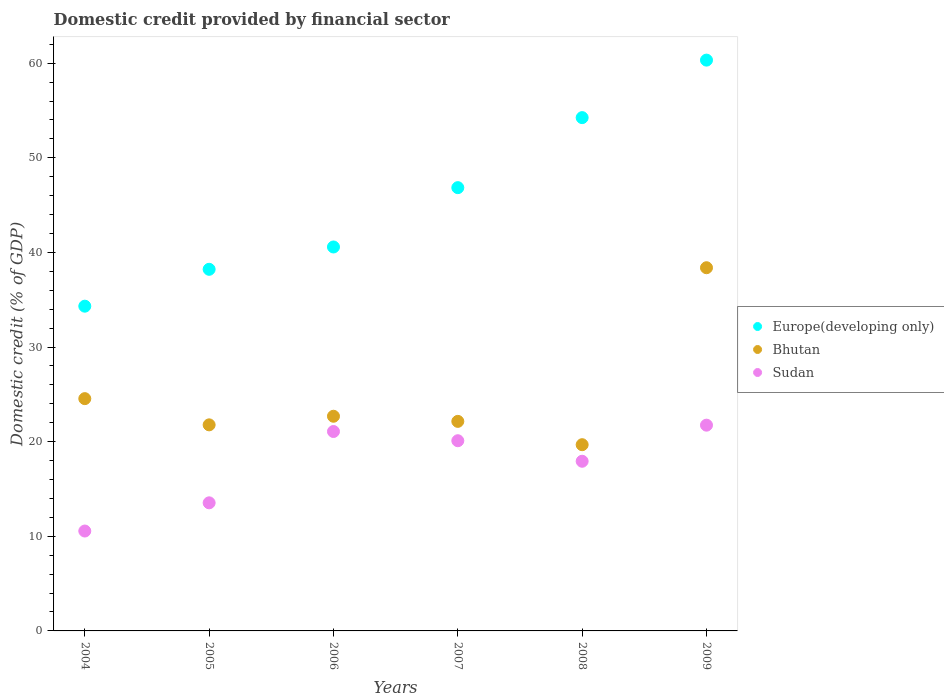What is the domestic credit in Bhutan in 2009?
Give a very brief answer. 38.38. Across all years, what is the maximum domestic credit in Sudan?
Provide a short and direct response. 21.75. Across all years, what is the minimum domestic credit in Bhutan?
Give a very brief answer. 19.68. In which year was the domestic credit in Europe(developing only) maximum?
Offer a terse response. 2009. In which year was the domestic credit in Bhutan minimum?
Offer a very short reply. 2008. What is the total domestic credit in Bhutan in the graph?
Ensure brevity in your answer.  149.23. What is the difference between the domestic credit in Bhutan in 2005 and that in 2008?
Ensure brevity in your answer.  2.1. What is the difference between the domestic credit in Bhutan in 2004 and the domestic credit in Europe(developing only) in 2009?
Provide a succinct answer. -35.78. What is the average domestic credit in Sudan per year?
Your answer should be compact. 17.49. In the year 2006, what is the difference between the domestic credit in Bhutan and domestic credit in Europe(developing only)?
Your response must be concise. -17.89. What is the ratio of the domestic credit in Sudan in 2006 to that in 2008?
Provide a succinct answer. 1.18. Is the domestic credit in Sudan in 2008 less than that in 2009?
Make the answer very short. Yes. What is the difference between the highest and the second highest domestic credit in Bhutan?
Ensure brevity in your answer.  13.84. What is the difference between the highest and the lowest domestic credit in Bhutan?
Make the answer very short. 18.7. In how many years, is the domestic credit in Bhutan greater than the average domestic credit in Bhutan taken over all years?
Offer a very short reply. 1. Is the sum of the domestic credit in Bhutan in 2006 and 2007 greater than the maximum domestic credit in Sudan across all years?
Offer a terse response. Yes. Is it the case that in every year, the sum of the domestic credit in Bhutan and domestic credit in Sudan  is greater than the domestic credit in Europe(developing only)?
Your answer should be compact. No. Does the domestic credit in Europe(developing only) monotonically increase over the years?
Give a very brief answer. Yes. Is the domestic credit in Europe(developing only) strictly greater than the domestic credit in Bhutan over the years?
Ensure brevity in your answer.  Yes. Is the domestic credit in Europe(developing only) strictly less than the domestic credit in Bhutan over the years?
Offer a terse response. No. How many dotlines are there?
Your response must be concise. 3. How many years are there in the graph?
Keep it short and to the point. 6. Does the graph contain any zero values?
Provide a short and direct response. No. Does the graph contain grids?
Offer a terse response. No. How many legend labels are there?
Your answer should be very brief. 3. How are the legend labels stacked?
Give a very brief answer. Vertical. What is the title of the graph?
Your response must be concise. Domestic credit provided by financial sector. Does "Trinidad and Tobago" appear as one of the legend labels in the graph?
Offer a very short reply. No. What is the label or title of the Y-axis?
Ensure brevity in your answer.  Domestic credit (% of GDP). What is the Domestic credit (% of GDP) of Europe(developing only) in 2004?
Offer a terse response. 34.32. What is the Domestic credit (% of GDP) of Bhutan in 2004?
Ensure brevity in your answer.  24.55. What is the Domestic credit (% of GDP) of Sudan in 2004?
Your response must be concise. 10.56. What is the Domestic credit (% of GDP) in Europe(developing only) in 2005?
Keep it short and to the point. 38.22. What is the Domestic credit (% of GDP) of Bhutan in 2005?
Provide a short and direct response. 21.78. What is the Domestic credit (% of GDP) in Sudan in 2005?
Offer a very short reply. 13.54. What is the Domestic credit (% of GDP) in Europe(developing only) in 2006?
Your response must be concise. 40.58. What is the Domestic credit (% of GDP) in Bhutan in 2006?
Offer a very short reply. 22.69. What is the Domestic credit (% of GDP) in Sudan in 2006?
Provide a succinct answer. 21.08. What is the Domestic credit (% of GDP) of Europe(developing only) in 2007?
Your answer should be very brief. 46.85. What is the Domestic credit (% of GDP) of Bhutan in 2007?
Your response must be concise. 22.15. What is the Domestic credit (% of GDP) of Sudan in 2007?
Make the answer very short. 20.1. What is the Domestic credit (% of GDP) in Europe(developing only) in 2008?
Your answer should be very brief. 54.25. What is the Domestic credit (% of GDP) of Bhutan in 2008?
Make the answer very short. 19.68. What is the Domestic credit (% of GDP) in Sudan in 2008?
Keep it short and to the point. 17.93. What is the Domestic credit (% of GDP) in Europe(developing only) in 2009?
Your answer should be compact. 60.33. What is the Domestic credit (% of GDP) of Bhutan in 2009?
Ensure brevity in your answer.  38.38. What is the Domestic credit (% of GDP) in Sudan in 2009?
Offer a very short reply. 21.75. Across all years, what is the maximum Domestic credit (% of GDP) in Europe(developing only)?
Your answer should be compact. 60.33. Across all years, what is the maximum Domestic credit (% of GDP) in Bhutan?
Provide a short and direct response. 38.38. Across all years, what is the maximum Domestic credit (% of GDP) in Sudan?
Offer a very short reply. 21.75. Across all years, what is the minimum Domestic credit (% of GDP) in Europe(developing only)?
Your response must be concise. 34.32. Across all years, what is the minimum Domestic credit (% of GDP) of Bhutan?
Give a very brief answer. 19.68. Across all years, what is the minimum Domestic credit (% of GDP) of Sudan?
Offer a terse response. 10.56. What is the total Domestic credit (% of GDP) of Europe(developing only) in the graph?
Your answer should be compact. 274.54. What is the total Domestic credit (% of GDP) in Bhutan in the graph?
Keep it short and to the point. 149.23. What is the total Domestic credit (% of GDP) in Sudan in the graph?
Make the answer very short. 104.95. What is the difference between the Domestic credit (% of GDP) in Europe(developing only) in 2004 and that in 2005?
Your response must be concise. -3.9. What is the difference between the Domestic credit (% of GDP) of Bhutan in 2004 and that in 2005?
Your answer should be compact. 2.77. What is the difference between the Domestic credit (% of GDP) in Sudan in 2004 and that in 2005?
Your response must be concise. -2.98. What is the difference between the Domestic credit (% of GDP) in Europe(developing only) in 2004 and that in 2006?
Your answer should be compact. -6.26. What is the difference between the Domestic credit (% of GDP) of Bhutan in 2004 and that in 2006?
Offer a very short reply. 1.86. What is the difference between the Domestic credit (% of GDP) of Sudan in 2004 and that in 2006?
Your answer should be compact. -10.52. What is the difference between the Domestic credit (% of GDP) of Europe(developing only) in 2004 and that in 2007?
Offer a terse response. -12.53. What is the difference between the Domestic credit (% of GDP) of Bhutan in 2004 and that in 2007?
Your answer should be very brief. 2.4. What is the difference between the Domestic credit (% of GDP) in Sudan in 2004 and that in 2007?
Make the answer very short. -9.54. What is the difference between the Domestic credit (% of GDP) in Europe(developing only) in 2004 and that in 2008?
Make the answer very short. -19.93. What is the difference between the Domestic credit (% of GDP) in Bhutan in 2004 and that in 2008?
Make the answer very short. 4.87. What is the difference between the Domestic credit (% of GDP) in Sudan in 2004 and that in 2008?
Keep it short and to the point. -7.37. What is the difference between the Domestic credit (% of GDP) of Europe(developing only) in 2004 and that in 2009?
Keep it short and to the point. -26.01. What is the difference between the Domestic credit (% of GDP) of Bhutan in 2004 and that in 2009?
Your answer should be compact. -13.84. What is the difference between the Domestic credit (% of GDP) in Sudan in 2004 and that in 2009?
Offer a very short reply. -11.19. What is the difference between the Domestic credit (% of GDP) in Europe(developing only) in 2005 and that in 2006?
Provide a short and direct response. -2.36. What is the difference between the Domestic credit (% of GDP) of Bhutan in 2005 and that in 2006?
Ensure brevity in your answer.  -0.91. What is the difference between the Domestic credit (% of GDP) of Sudan in 2005 and that in 2006?
Offer a terse response. -7.54. What is the difference between the Domestic credit (% of GDP) in Europe(developing only) in 2005 and that in 2007?
Your answer should be very brief. -8.63. What is the difference between the Domestic credit (% of GDP) in Bhutan in 2005 and that in 2007?
Offer a very short reply. -0.37. What is the difference between the Domestic credit (% of GDP) of Sudan in 2005 and that in 2007?
Ensure brevity in your answer.  -6.56. What is the difference between the Domestic credit (% of GDP) in Europe(developing only) in 2005 and that in 2008?
Give a very brief answer. -16.03. What is the difference between the Domestic credit (% of GDP) in Bhutan in 2005 and that in 2008?
Ensure brevity in your answer.  2.1. What is the difference between the Domestic credit (% of GDP) of Sudan in 2005 and that in 2008?
Your response must be concise. -4.39. What is the difference between the Domestic credit (% of GDP) of Europe(developing only) in 2005 and that in 2009?
Make the answer very short. -22.11. What is the difference between the Domestic credit (% of GDP) of Bhutan in 2005 and that in 2009?
Ensure brevity in your answer.  -16.61. What is the difference between the Domestic credit (% of GDP) in Sudan in 2005 and that in 2009?
Your response must be concise. -8.21. What is the difference between the Domestic credit (% of GDP) in Europe(developing only) in 2006 and that in 2007?
Keep it short and to the point. -6.27. What is the difference between the Domestic credit (% of GDP) of Bhutan in 2006 and that in 2007?
Ensure brevity in your answer.  0.54. What is the difference between the Domestic credit (% of GDP) in Sudan in 2006 and that in 2007?
Keep it short and to the point. 0.97. What is the difference between the Domestic credit (% of GDP) in Europe(developing only) in 2006 and that in 2008?
Offer a terse response. -13.67. What is the difference between the Domestic credit (% of GDP) in Bhutan in 2006 and that in 2008?
Ensure brevity in your answer.  3.01. What is the difference between the Domestic credit (% of GDP) of Sudan in 2006 and that in 2008?
Offer a very short reply. 3.14. What is the difference between the Domestic credit (% of GDP) in Europe(developing only) in 2006 and that in 2009?
Give a very brief answer. -19.75. What is the difference between the Domestic credit (% of GDP) of Bhutan in 2006 and that in 2009?
Make the answer very short. -15.7. What is the difference between the Domestic credit (% of GDP) in Sudan in 2006 and that in 2009?
Ensure brevity in your answer.  -0.67. What is the difference between the Domestic credit (% of GDP) in Europe(developing only) in 2007 and that in 2008?
Offer a terse response. -7.4. What is the difference between the Domestic credit (% of GDP) in Bhutan in 2007 and that in 2008?
Your answer should be very brief. 2.47. What is the difference between the Domestic credit (% of GDP) of Sudan in 2007 and that in 2008?
Provide a succinct answer. 2.17. What is the difference between the Domestic credit (% of GDP) in Europe(developing only) in 2007 and that in 2009?
Your answer should be very brief. -13.48. What is the difference between the Domestic credit (% of GDP) in Bhutan in 2007 and that in 2009?
Keep it short and to the point. -16.24. What is the difference between the Domestic credit (% of GDP) of Sudan in 2007 and that in 2009?
Your answer should be compact. -1.65. What is the difference between the Domestic credit (% of GDP) in Europe(developing only) in 2008 and that in 2009?
Offer a very short reply. -6.08. What is the difference between the Domestic credit (% of GDP) of Bhutan in 2008 and that in 2009?
Ensure brevity in your answer.  -18.7. What is the difference between the Domestic credit (% of GDP) of Sudan in 2008 and that in 2009?
Offer a terse response. -3.81. What is the difference between the Domestic credit (% of GDP) of Europe(developing only) in 2004 and the Domestic credit (% of GDP) of Bhutan in 2005?
Offer a terse response. 12.54. What is the difference between the Domestic credit (% of GDP) in Europe(developing only) in 2004 and the Domestic credit (% of GDP) in Sudan in 2005?
Offer a terse response. 20.78. What is the difference between the Domestic credit (% of GDP) of Bhutan in 2004 and the Domestic credit (% of GDP) of Sudan in 2005?
Ensure brevity in your answer.  11.01. What is the difference between the Domestic credit (% of GDP) of Europe(developing only) in 2004 and the Domestic credit (% of GDP) of Bhutan in 2006?
Provide a succinct answer. 11.63. What is the difference between the Domestic credit (% of GDP) of Europe(developing only) in 2004 and the Domestic credit (% of GDP) of Sudan in 2006?
Give a very brief answer. 13.24. What is the difference between the Domestic credit (% of GDP) of Bhutan in 2004 and the Domestic credit (% of GDP) of Sudan in 2006?
Keep it short and to the point. 3.47. What is the difference between the Domestic credit (% of GDP) of Europe(developing only) in 2004 and the Domestic credit (% of GDP) of Bhutan in 2007?
Give a very brief answer. 12.17. What is the difference between the Domestic credit (% of GDP) in Europe(developing only) in 2004 and the Domestic credit (% of GDP) in Sudan in 2007?
Your answer should be very brief. 14.22. What is the difference between the Domestic credit (% of GDP) in Bhutan in 2004 and the Domestic credit (% of GDP) in Sudan in 2007?
Offer a very short reply. 4.45. What is the difference between the Domestic credit (% of GDP) of Europe(developing only) in 2004 and the Domestic credit (% of GDP) of Bhutan in 2008?
Ensure brevity in your answer.  14.64. What is the difference between the Domestic credit (% of GDP) in Europe(developing only) in 2004 and the Domestic credit (% of GDP) in Sudan in 2008?
Your answer should be compact. 16.39. What is the difference between the Domestic credit (% of GDP) in Bhutan in 2004 and the Domestic credit (% of GDP) in Sudan in 2008?
Give a very brief answer. 6.62. What is the difference between the Domestic credit (% of GDP) in Europe(developing only) in 2004 and the Domestic credit (% of GDP) in Bhutan in 2009?
Provide a succinct answer. -4.06. What is the difference between the Domestic credit (% of GDP) of Europe(developing only) in 2004 and the Domestic credit (% of GDP) of Sudan in 2009?
Make the answer very short. 12.57. What is the difference between the Domestic credit (% of GDP) of Bhutan in 2004 and the Domestic credit (% of GDP) of Sudan in 2009?
Keep it short and to the point. 2.8. What is the difference between the Domestic credit (% of GDP) in Europe(developing only) in 2005 and the Domestic credit (% of GDP) in Bhutan in 2006?
Offer a very short reply. 15.53. What is the difference between the Domestic credit (% of GDP) in Europe(developing only) in 2005 and the Domestic credit (% of GDP) in Sudan in 2006?
Your answer should be compact. 17.14. What is the difference between the Domestic credit (% of GDP) in Bhutan in 2005 and the Domestic credit (% of GDP) in Sudan in 2006?
Offer a very short reply. 0.7. What is the difference between the Domestic credit (% of GDP) of Europe(developing only) in 2005 and the Domestic credit (% of GDP) of Bhutan in 2007?
Give a very brief answer. 16.07. What is the difference between the Domestic credit (% of GDP) of Europe(developing only) in 2005 and the Domestic credit (% of GDP) of Sudan in 2007?
Offer a terse response. 18.12. What is the difference between the Domestic credit (% of GDP) of Bhutan in 2005 and the Domestic credit (% of GDP) of Sudan in 2007?
Give a very brief answer. 1.68. What is the difference between the Domestic credit (% of GDP) in Europe(developing only) in 2005 and the Domestic credit (% of GDP) in Bhutan in 2008?
Your response must be concise. 18.54. What is the difference between the Domestic credit (% of GDP) in Europe(developing only) in 2005 and the Domestic credit (% of GDP) in Sudan in 2008?
Make the answer very short. 20.29. What is the difference between the Domestic credit (% of GDP) in Bhutan in 2005 and the Domestic credit (% of GDP) in Sudan in 2008?
Offer a terse response. 3.85. What is the difference between the Domestic credit (% of GDP) in Europe(developing only) in 2005 and the Domestic credit (% of GDP) in Bhutan in 2009?
Offer a terse response. -0.17. What is the difference between the Domestic credit (% of GDP) in Europe(developing only) in 2005 and the Domestic credit (% of GDP) in Sudan in 2009?
Offer a very short reply. 16.47. What is the difference between the Domestic credit (% of GDP) of Europe(developing only) in 2006 and the Domestic credit (% of GDP) of Bhutan in 2007?
Provide a succinct answer. 18.43. What is the difference between the Domestic credit (% of GDP) in Europe(developing only) in 2006 and the Domestic credit (% of GDP) in Sudan in 2007?
Provide a short and direct response. 20.48. What is the difference between the Domestic credit (% of GDP) of Bhutan in 2006 and the Domestic credit (% of GDP) of Sudan in 2007?
Your answer should be very brief. 2.59. What is the difference between the Domestic credit (% of GDP) in Europe(developing only) in 2006 and the Domestic credit (% of GDP) in Bhutan in 2008?
Ensure brevity in your answer.  20.9. What is the difference between the Domestic credit (% of GDP) in Europe(developing only) in 2006 and the Domestic credit (% of GDP) in Sudan in 2008?
Your answer should be very brief. 22.65. What is the difference between the Domestic credit (% of GDP) in Bhutan in 2006 and the Domestic credit (% of GDP) in Sudan in 2008?
Your answer should be very brief. 4.76. What is the difference between the Domestic credit (% of GDP) of Europe(developing only) in 2006 and the Domestic credit (% of GDP) of Bhutan in 2009?
Your answer should be very brief. 2.19. What is the difference between the Domestic credit (% of GDP) of Europe(developing only) in 2006 and the Domestic credit (% of GDP) of Sudan in 2009?
Ensure brevity in your answer.  18.83. What is the difference between the Domestic credit (% of GDP) of Bhutan in 2006 and the Domestic credit (% of GDP) of Sudan in 2009?
Your answer should be very brief. 0.94. What is the difference between the Domestic credit (% of GDP) in Europe(developing only) in 2007 and the Domestic credit (% of GDP) in Bhutan in 2008?
Keep it short and to the point. 27.17. What is the difference between the Domestic credit (% of GDP) in Europe(developing only) in 2007 and the Domestic credit (% of GDP) in Sudan in 2008?
Keep it short and to the point. 28.92. What is the difference between the Domestic credit (% of GDP) of Bhutan in 2007 and the Domestic credit (% of GDP) of Sudan in 2008?
Offer a terse response. 4.21. What is the difference between the Domestic credit (% of GDP) in Europe(developing only) in 2007 and the Domestic credit (% of GDP) in Bhutan in 2009?
Your answer should be very brief. 8.46. What is the difference between the Domestic credit (% of GDP) in Europe(developing only) in 2007 and the Domestic credit (% of GDP) in Sudan in 2009?
Ensure brevity in your answer.  25.1. What is the difference between the Domestic credit (% of GDP) in Bhutan in 2007 and the Domestic credit (% of GDP) in Sudan in 2009?
Offer a terse response. 0.4. What is the difference between the Domestic credit (% of GDP) of Europe(developing only) in 2008 and the Domestic credit (% of GDP) of Bhutan in 2009?
Make the answer very short. 15.86. What is the difference between the Domestic credit (% of GDP) in Europe(developing only) in 2008 and the Domestic credit (% of GDP) in Sudan in 2009?
Keep it short and to the point. 32.5. What is the difference between the Domestic credit (% of GDP) of Bhutan in 2008 and the Domestic credit (% of GDP) of Sudan in 2009?
Provide a short and direct response. -2.06. What is the average Domestic credit (% of GDP) of Europe(developing only) per year?
Make the answer very short. 45.76. What is the average Domestic credit (% of GDP) of Bhutan per year?
Keep it short and to the point. 24.87. What is the average Domestic credit (% of GDP) of Sudan per year?
Your answer should be compact. 17.49. In the year 2004, what is the difference between the Domestic credit (% of GDP) of Europe(developing only) and Domestic credit (% of GDP) of Bhutan?
Your answer should be compact. 9.77. In the year 2004, what is the difference between the Domestic credit (% of GDP) in Europe(developing only) and Domestic credit (% of GDP) in Sudan?
Keep it short and to the point. 23.76. In the year 2004, what is the difference between the Domestic credit (% of GDP) in Bhutan and Domestic credit (% of GDP) in Sudan?
Give a very brief answer. 13.99. In the year 2005, what is the difference between the Domestic credit (% of GDP) in Europe(developing only) and Domestic credit (% of GDP) in Bhutan?
Ensure brevity in your answer.  16.44. In the year 2005, what is the difference between the Domestic credit (% of GDP) of Europe(developing only) and Domestic credit (% of GDP) of Sudan?
Your answer should be very brief. 24.68. In the year 2005, what is the difference between the Domestic credit (% of GDP) of Bhutan and Domestic credit (% of GDP) of Sudan?
Your response must be concise. 8.24. In the year 2006, what is the difference between the Domestic credit (% of GDP) in Europe(developing only) and Domestic credit (% of GDP) in Bhutan?
Keep it short and to the point. 17.89. In the year 2006, what is the difference between the Domestic credit (% of GDP) of Europe(developing only) and Domestic credit (% of GDP) of Sudan?
Your answer should be very brief. 19.5. In the year 2006, what is the difference between the Domestic credit (% of GDP) of Bhutan and Domestic credit (% of GDP) of Sudan?
Ensure brevity in your answer.  1.61. In the year 2007, what is the difference between the Domestic credit (% of GDP) in Europe(developing only) and Domestic credit (% of GDP) in Bhutan?
Provide a short and direct response. 24.7. In the year 2007, what is the difference between the Domestic credit (% of GDP) in Europe(developing only) and Domestic credit (% of GDP) in Sudan?
Ensure brevity in your answer.  26.75. In the year 2007, what is the difference between the Domestic credit (% of GDP) in Bhutan and Domestic credit (% of GDP) in Sudan?
Provide a succinct answer. 2.05. In the year 2008, what is the difference between the Domestic credit (% of GDP) of Europe(developing only) and Domestic credit (% of GDP) of Bhutan?
Offer a very short reply. 34.57. In the year 2008, what is the difference between the Domestic credit (% of GDP) in Europe(developing only) and Domestic credit (% of GDP) in Sudan?
Your answer should be compact. 36.32. In the year 2008, what is the difference between the Domestic credit (% of GDP) of Bhutan and Domestic credit (% of GDP) of Sudan?
Ensure brevity in your answer.  1.75. In the year 2009, what is the difference between the Domestic credit (% of GDP) of Europe(developing only) and Domestic credit (% of GDP) of Bhutan?
Provide a succinct answer. 21.94. In the year 2009, what is the difference between the Domestic credit (% of GDP) of Europe(developing only) and Domestic credit (% of GDP) of Sudan?
Offer a terse response. 38.58. In the year 2009, what is the difference between the Domestic credit (% of GDP) in Bhutan and Domestic credit (% of GDP) in Sudan?
Make the answer very short. 16.64. What is the ratio of the Domestic credit (% of GDP) of Europe(developing only) in 2004 to that in 2005?
Provide a short and direct response. 0.9. What is the ratio of the Domestic credit (% of GDP) of Bhutan in 2004 to that in 2005?
Your response must be concise. 1.13. What is the ratio of the Domestic credit (% of GDP) of Sudan in 2004 to that in 2005?
Offer a terse response. 0.78. What is the ratio of the Domestic credit (% of GDP) in Europe(developing only) in 2004 to that in 2006?
Give a very brief answer. 0.85. What is the ratio of the Domestic credit (% of GDP) of Bhutan in 2004 to that in 2006?
Ensure brevity in your answer.  1.08. What is the ratio of the Domestic credit (% of GDP) in Sudan in 2004 to that in 2006?
Ensure brevity in your answer.  0.5. What is the ratio of the Domestic credit (% of GDP) of Europe(developing only) in 2004 to that in 2007?
Give a very brief answer. 0.73. What is the ratio of the Domestic credit (% of GDP) in Bhutan in 2004 to that in 2007?
Provide a short and direct response. 1.11. What is the ratio of the Domestic credit (% of GDP) of Sudan in 2004 to that in 2007?
Offer a terse response. 0.53. What is the ratio of the Domestic credit (% of GDP) of Europe(developing only) in 2004 to that in 2008?
Your answer should be very brief. 0.63. What is the ratio of the Domestic credit (% of GDP) in Bhutan in 2004 to that in 2008?
Offer a terse response. 1.25. What is the ratio of the Domestic credit (% of GDP) in Sudan in 2004 to that in 2008?
Ensure brevity in your answer.  0.59. What is the ratio of the Domestic credit (% of GDP) of Europe(developing only) in 2004 to that in 2009?
Provide a succinct answer. 0.57. What is the ratio of the Domestic credit (% of GDP) of Bhutan in 2004 to that in 2009?
Make the answer very short. 0.64. What is the ratio of the Domestic credit (% of GDP) of Sudan in 2004 to that in 2009?
Your answer should be compact. 0.49. What is the ratio of the Domestic credit (% of GDP) in Europe(developing only) in 2005 to that in 2006?
Your response must be concise. 0.94. What is the ratio of the Domestic credit (% of GDP) in Bhutan in 2005 to that in 2006?
Keep it short and to the point. 0.96. What is the ratio of the Domestic credit (% of GDP) in Sudan in 2005 to that in 2006?
Give a very brief answer. 0.64. What is the ratio of the Domestic credit (% of GDP) in Europe(developing only) in 2005 to that in 2007?
Your answer should be very brief. 0.82. What is the ratio of the Domestic credit (% of GDP) in Bhutan in 2005 to that in 2007?
Your answer should be very brief. 0.98. What is the ratio of the Domestic credit (% of GDP) of Sudan in 2005 to that in 2007?
Offer a terse response. 0.67. What is the ratio of the Domestic credit (% of GDP) of Europe(developing only) in 2005 to that in 2008?
Offer a terse response. 0.7. What is the ratio of the Domestic credit (% of GDP) of Bhutan in 2005 to that in 2008?
Provide a succinct answer. 1.11. What is the ratio of the Domestic credit (% of GDP) of Sudan in 2005 to that in 2008?
Your answer should be very brief. 0.76. What is the ratio of the Domestic credit (% of GDP) of Europe(developing only) in 2005 to that in 2009?
Ensure brevity in your answer.  0.63. What is the ratio of the Domestic credit (% of GDP) of Bhutan in 2005 to that in 2009?
Ensure brevity in your answer.  0.57. What is the ratio of the Domestic credit (% of GDP) of Sudan in 2005 to that in 2009?
Provide a short and direct response. 0.62. What is the ratio of the Domestic credit (% of GDP) of Europe(developing only) in 2006 to that in 2007?
Provide a succinct answer. 0.87. What is the ratio of the Domestic credit (% of GDP) in Bhutan in 2006 to that in 2007?
Provide a succinct answer. 1.02. What is the ratio of the Domestic credit (% of GDP) in Sudan in 2006 to that in 2007?
Give a very brief answer. 1.05. What is the ratio of the Domestic credit (% of GDP) of Europe(developing only) in 2006 to that in 2008?
Your response must be concise. 0.75. What is the ratio of the Domestic credit (% of GDP) of Bhutan in 2006 to that in 2008?
Provide a short and direct response. 1.15. What is the ratio of the Domestic credit (% of GDP) of Sudan in 2006 to that in 2008?
Your response must be concise. 1.18. What is the ratio of the Domestic credit (% of GDP) in Europe(developing only) in 2006 to that in 2009?
Make the answer very short. 0.67. What is the ratio of the Domestic credit (% of GDP) in Bhutan in 2006 to that in 2009?
Provide a short and direct response. 0.59. What is the ratio of the Domestic credit (% of GDP) in Sudan in 2006 to that in 2009?
Offer a terse response. 0.97. What is the ratio of the Domestic credit (% of GDP) of Europe(developing only) in 2007 to that in 2008?
Keep it short and to the point. 0.86. What is the ratio of the Domestic credit (% of GDP) in Bhutan in 2007 to that in 2008?
Ensure brevity in your answer.  1.13. What is the ratio of the Domestic credit (% of GDP) in Sudan in 2007 to that in 2008?
Your answer should be very brief. 1.12. What is the ratio of the Domestic credit (% of GDP) in Europe(developing only) in 2007 to that in 2009?
Offer a very short reply. 0.78. What is the ratio of the Domestic credit (% of GDP) of Bhutan in 2007 to that in 2009?
Provide a succinct answer. 0.58. What is the ratio of the Domestic credit (% of GDP) in Sudan in 2007 to that in 2009?
Provide a succinct answer. 0.92. What is the ratio of the Domestic credit (% of GDP) in Europe(developing only) in 2008 to that in 2009?
Your response must be concise. 0.9. What is the ratio of the Domestic credit (% of GDP) in Bhutan in 2008 to that in 2009?
Provide a short and direct response. 0.51. What is the ratio of the Domestic credit (% of GDP) of Sudan in 2008 to that in 2009?
Keep it short and to the point. 0.82. What is the difference between the highest and the second highest Domestic credit (% of GDP) in Europe(developing only)?
Your answer should be very brief. 6.08. What is the difference between the highest and the second highest Domestic credit (% of GDP) in Bhutan?
Offer a terse response. 13.84. What is the difference between the highest and the second highest Domestic credit (% of GDP) of Sudan?
Make the answer very short. 0.67. What is the difference between the highest and the lowest Domestic credit (% of GDP) in Europe(developing only)?
Give a very brief answer. 26.01. What is the difference between the highest and the lowest Domestic credit (% of GDP) of Bhutan?
Keep it short and to the point. 18.7. What is the difference between the highest and the lowest Domestic credit (% of GDP) of Sudan?
Ensure brevity in your answer.  11.19. 